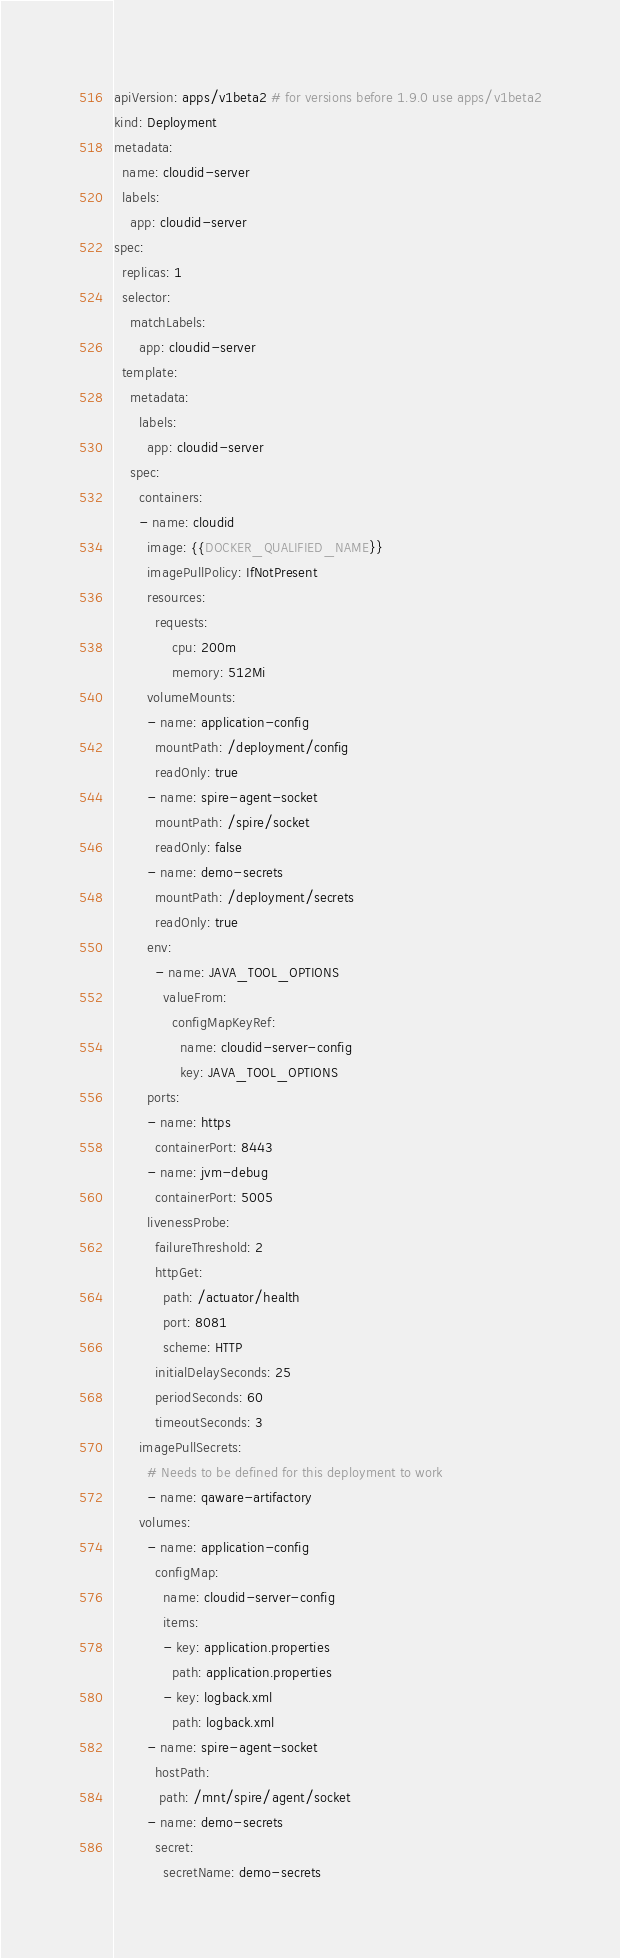<code> <loc_0><loc_0><loc_500><loc_500><_YAML_>apiVersion: apps/v1beta2 # for versions before 1.9.0 use apps/v1beta2
kind: Deployment
metadata:
  name: cloudid-server
  labels:
    app: cloudid-server
spec:
  replicas: 1
  selector:
    matchLabels:
      app: cloudid-server
  template:
    metadata:
      labels:
        app: cloudid-server
    spec:
      containers:
      - name: cloudid
        image: {{DOCKER_QUALIFIED_NAME}}
        imagePullPolicy: IfNotPresent
        resources:
          requests:
              cpu: 200m
              memory: 512Mi
        volumeMounts:
        - name: application-config
          mountPath: /deployment/config
          readOnly: true
        - name: spire-agent-socket
          mountPath: /spire/socket
          readOnly: false
        - name: demo-secrets
          mountPath: /deployment/secrets
          readOnly: true
        env:
          - name: JAVA_TOOL_OPTIONS
            valueFrom:
              configMapKeyRef:
                name: cloudid-server-config
                key: JAVA_TOOL_OPTIONS
        ports:
        - name: https
          containerPort: 8443
        - name: jvm-debug
          containerPort: 5005
        livenessProbe:
          failureThreshold: 2
          httpGet:
            path: /actuator/health
            port: 8081
            scheme: HTTP
          initialDelaySeconds: 25
          periodSeconds: 60
          timeoutSeconds: 3
      imagePullSecrets:
        # Needs to be defined for this deployment to work
        - name: qaware-artifactory
      volumes:
        - name: application-config
          configMap:
            name: cloudid-server-config
            items:
            - key: application.properties
              path: application.properties
            - key: logback.xml
              path: logback.xml
        - name: spire-agent-socket
          hostPath:
           path: /mnt/spire/agent/socket
        - name: demo-secrets
          secret:
            secretName: demo-secrets</code> 